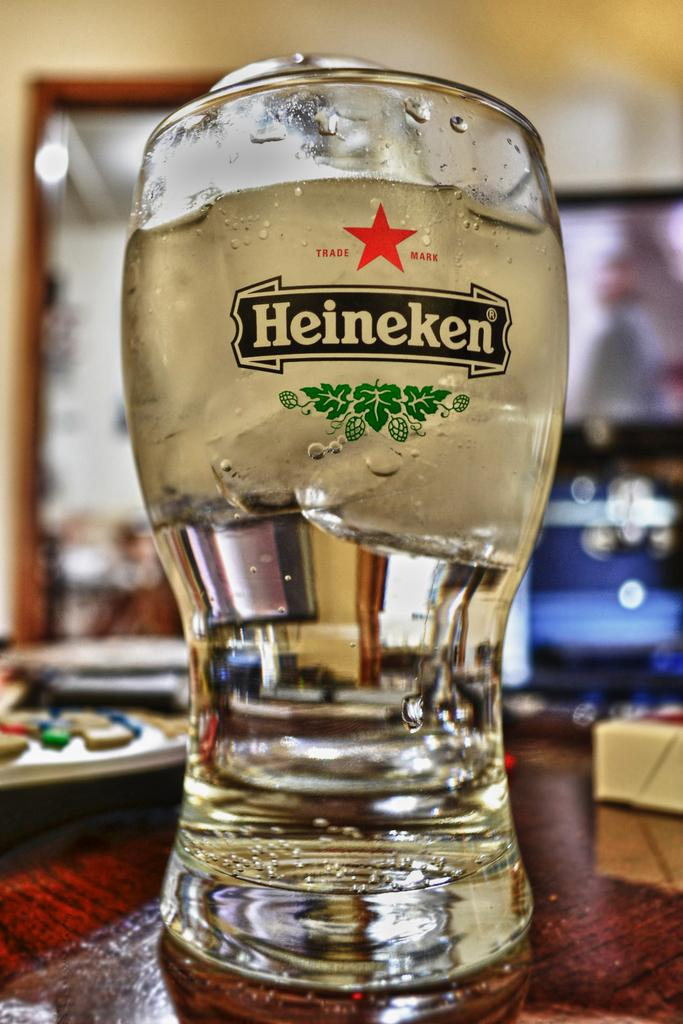<image>
Present a compact description of the photo's key features. A glass with Heineken on it and a red star. 